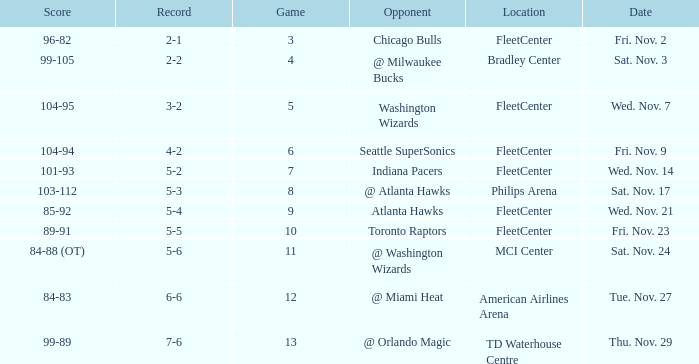On what date did Fleetcenter have a game lower than 9 with a score of 104-94? Fri. Nov. 9. 